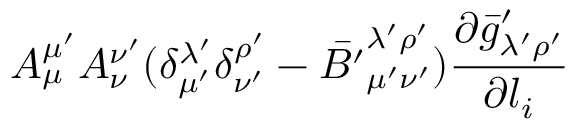<formula> <loc_0><loc_0><loc_500><loc_500>A _ { \mu } ^ { \mu ^ { \prime } } A _ { \nu } ^ { \nu ^ { \prime } } ( \delta _ { \mu ^ { \prime } } ^ { \lambda ^ { \prime } } \delta _ { \nu ^ { \prime } } ^ { \rho ^ { \prime } } - { \bar { B ^ { \prime } } } _ { \mu ^ { \prime } \nu ^ { \prime } } ^ { \lambda ^ { \prime } \rho ^ { \prime } } ) \frac { \partial { \bar { g } ^ { \prime } } _ { \lambda ^ { \prime } \rho ^ { \prime } } } { \partial l _ { i } }</formula> 